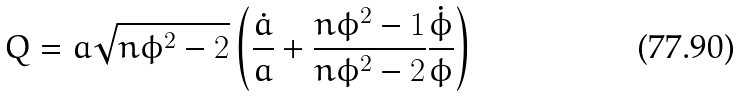<formula> <loc_0><loc_0><loc_500><loc_500>Q = a \sqrt { n \phi ^ { 2 } - 2 } \left ( \frac { \dot { a } } { a } + \frac { n \phi ^ { 2 } - 1 } { n \phi ^ { 2 } - 2 } \frac { \dot { \phi } } { \phi } \right )</formula> 